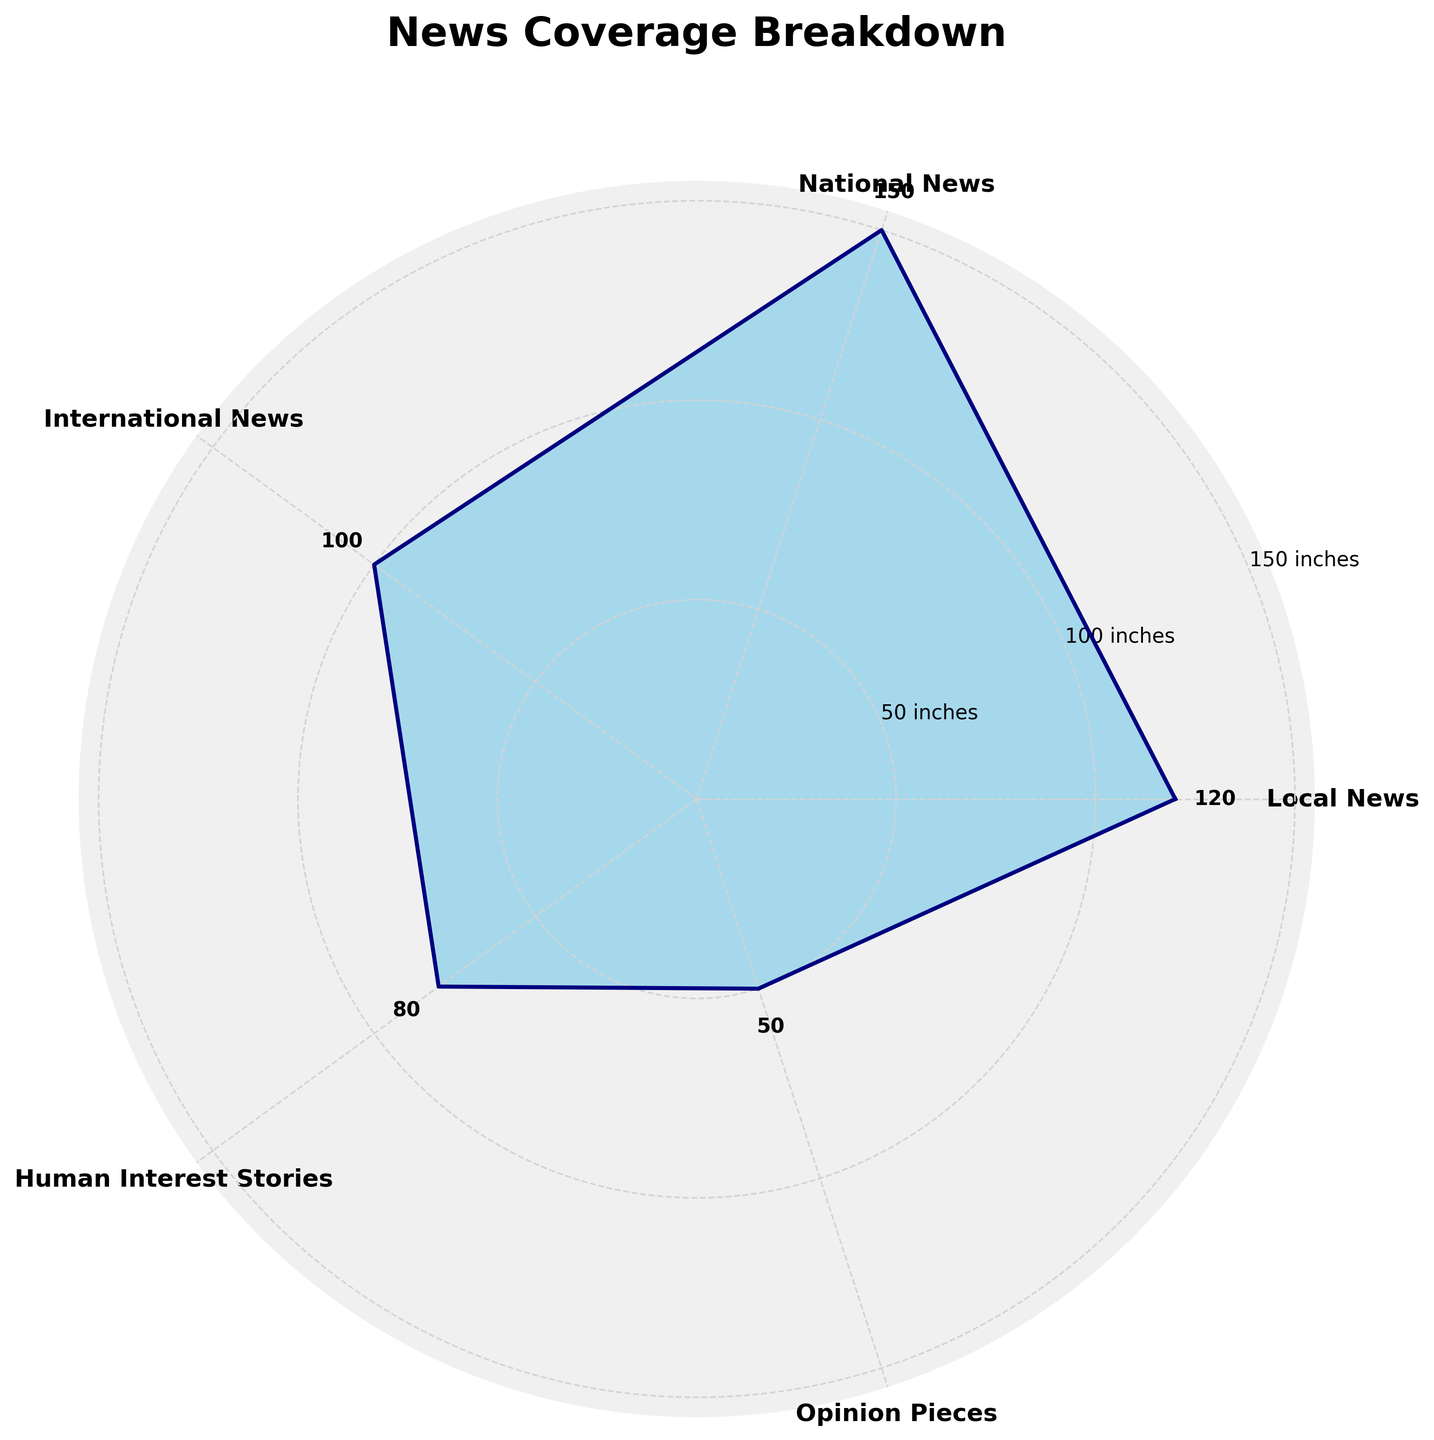What title is displayed on the figure? The title is usually displayed at the top of the figure. In this case, it reads "News Coverage Breakdown" as indicated in the code.
Answer: News Coverage Breakdown Which topic has the highest column inches dedicated? By visually inspecting the lengths of the areas filled on the plot, the segment with the largest area represents National News.
Answer: National News What is the value of column inches for Opinion Pieces? Looking at the data labels or the radial ticks near the Opinion Pieces segment, the value is indicated as 50 inches.
Answer: 50 Which topics have values greater than 100 column inches? By comparing the lengths of the filled areas to the radial ticks, Local News and National News both extend beyond the 100-inch tick mark.
Answer: Local News, National News What is the difference in column inches between National News and Human Interest Stories? National News has 150 inches and Human Interest Stories have 80 inches. The difference is calculated as 150 - 80.
Answer: 70 inches Which topic has the smallest column inches dedicated? Looking at the lengths of the segments, the smallest segment corresponds to Opinion Pieces.
Answer: Opinion Pieces What is the sum of column inches dedicated to Local News and International News? Local News has 120 inches, and International News has 100 inches. The sum is calculated as 120 + 100.
Answer: 220 inches Compare the lengths of the segments for Local News and National News. Which one is greater and by how much? National News has 150 inches, and Local News has 120 inches. National News is greater, and the difference is 150 - 120.
Answer: National News by 30 inches By how much do Human Interest Stories contribute to the total column inches? The total column inches for all topics is the sum of the individual values: 120 (Local News) + 150 (National News) + 100 (International News) + 80 (Human Interest Stories) + 50 (Opinion Pieces) = 500 inches. The contribution from Human Interest Stories is calculated as (80 / 500) * 100%.
Answer: 16% What is the average column inches dedicated to each topic? The total column inches for all topics is 500 inches, and there are 5 topics. The average is calculated by dividing the total by the number of topics: 500 / 5.
Answer: 100 inches Which topics are closest in their column inch values? By comparing the values, International News (100) and Human Interest Stories (80) are the closest, with a difference of 20 inches.
Answer: International News and Human Interest Stories 